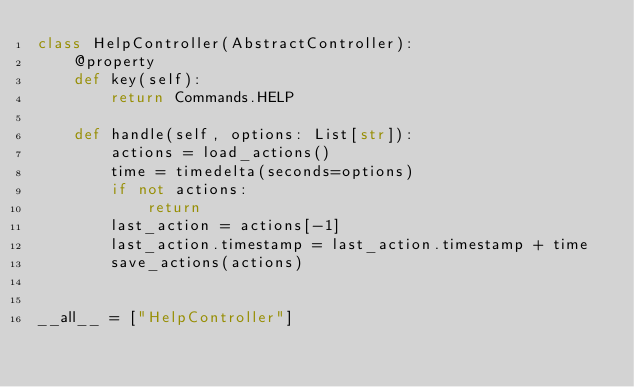<code> <loc_0><loc_0><loc_500><loc_500><_Python_>class HelpController(AbstractController):
    @property
    def key(self):
        return Commands.HELP

    def handle(self, options: List[str]):
        actions = load_actions()
        time = timedelta(seconds=options)
        if not actions:
            return
        last_action = actions[-1]
        last_action.timestamp = last_action.timestamp + time
        save_actions(actions)


__all__ = ["HelpController"]
</code> 